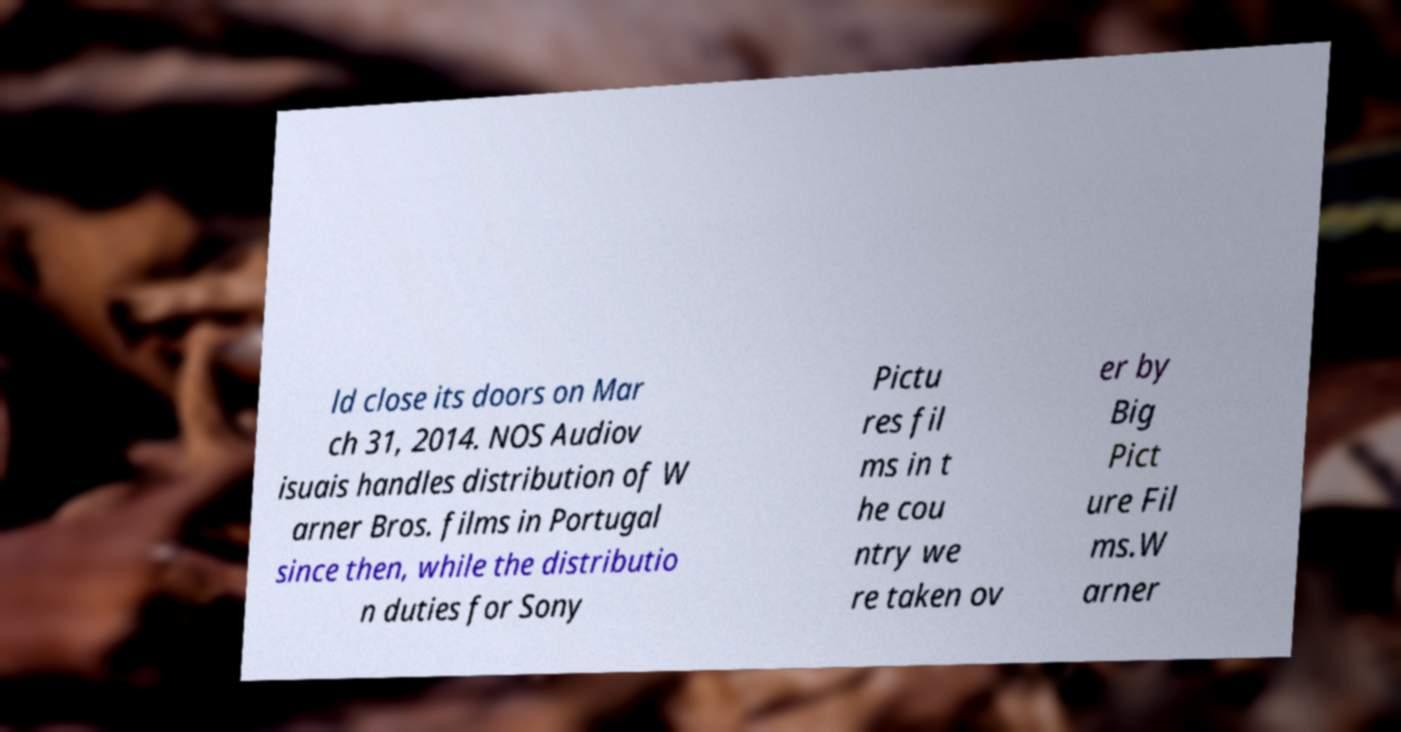Can you read and provide the text displayed in the image?This photo seems to have some interesting text. Can you extract and type it out for me? ld close its doors on Mar ch 31, 2014. NOS Audiov isuais handles distribution of W arner Bros. films in Portugal since then, while the distributio n duties for Sony Pictu res fil ms in t he cou ntry we re taken ov er by Big Pict ure Fil ms.W arner 